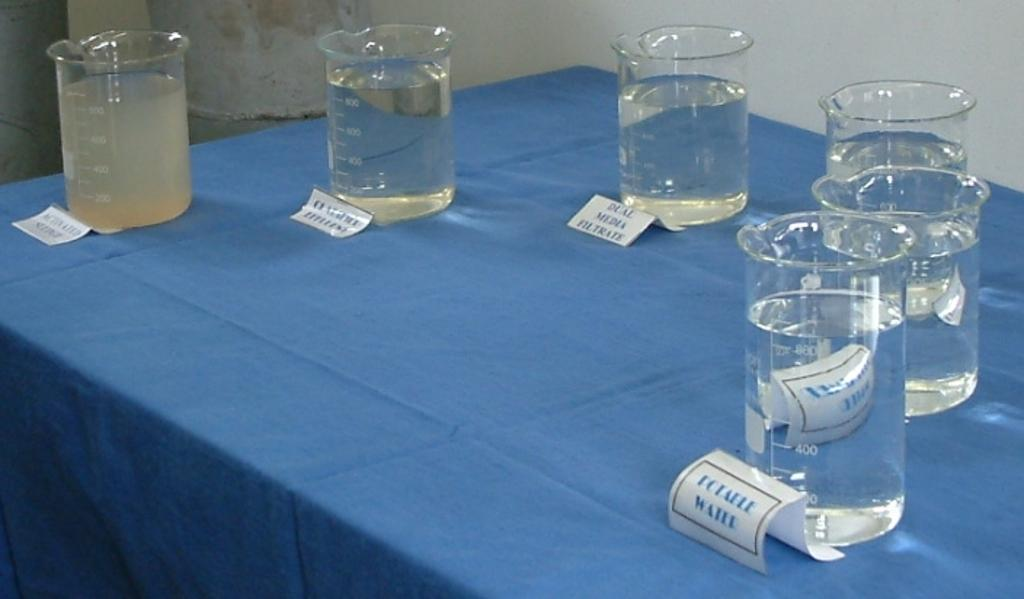<image>
Render a clear and concise summary of the photo. Dual media filtrate water sitting on a table. 